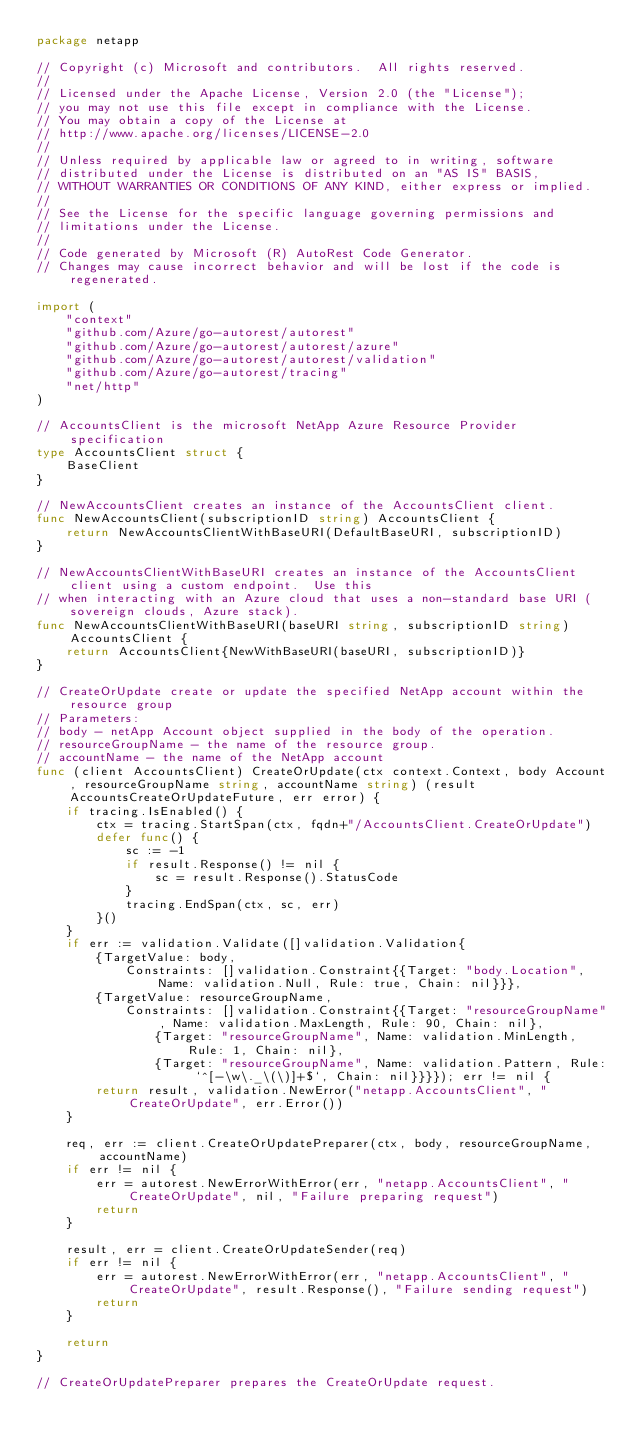Convert code to text. <code><loc_0><loc_0><loc_500><loc_500><_Go_>package netapp

// Copyright (c) Microsoft and contributors.  All rights reserved.
//
// Licensed under the Apache License, Version 2.0 (the "License");
// you may not use this file except in compliance with the License.
// You may obtain a copy of the License at
// http://www.apache.org/licenses/LICENSE-2.0
//
// Unless required by applicable law or agreed to in writing, software
// distributed under the License is distributed on an "AS IS" BASIS,
// WITHOUT WARRANTIES OR CONDITIONS OF ANY KIND, either express or implied.
//
// See the License for the specific language governing permissions and
// limitations under the License.
//
// Code generated by Microsoft (R) AutoRest Code Generator.
// Changes may cause incorrect behavior and will be lost if the code is regenerated.

import (
	"context"
	"github.com/Azure/go-autorest/autorest"
	"github.com/Azure/go-autorest/autorest/azure"
	"github.com/Azure/go-autorest/autorest/validation"
	"github.com/Azure/go-autorest/tracing"
	"net/http"
)

// AccountsClient is the microsoft NetApp Azure Resource Provider specification
type AccountsClient struct {
	BaseClient
}

// NewAccountsClient creates an instance of the AccountsClient client.
func NewAccountsClient(subscriptionID string) AccountsClient {
	return NewAccountsClientWithBaseURI(DefaultBaseURI, subscriptionID)
}

// NewAccountsClientWithBaseURI creates an instance of the AccountsClient client using a custom endpoint.  Use this
// when interacting with an Azure cloud that uses a non-standard base URI (sovereign clouds, Azure stack).
func NewAccountsClientWithBaseURI(baseURI string, subscriptionID string) AccountsClient {
	return AccountsClient{NewWithBaseURI(baseURI, subscriptionID)}
}

// CreateOrUpdate create or update the specified NetApp account within the resource group
// Parameters:
// body - netApp Account object supplied in the body of the operation.
// resourceGroupName - the name of the resource group.
// accountName - the name of the NetApp account
func (client AccountsClient) CreateOrUpdate(ctx context.Context, body Account, resourceGroupName string, accountName string) (result AccountsCreateOrUpdateFuture, err error) {
	if tracing.IsEnabled() {
		ctx = tracing.StartSpan(ctx, fqdn+"/AccountsClient.CreateOrUpdate")
		defer func() {
			sc := -1
			if result.Response() != nil {
				sc = result.Response().StatusCode
			}
			tracing.EndSpan(ctx, sc, err)
		}()
	}
	if err := validation.Validate([]validation.Validation{
		{TargetValue: body,
			Constraints: []validation.Constraint{{Target: "body.Location", Name: validation.Null, Rule: true, Chain: nil}}},
		{TargetValue: resourceGroupName,
			Constraints: []validation.Constraint{{Target: "resourceGroupName", Name: validation.MaxLength, Rule: 90, Chain: nil},
				{Target: "resourceGroupName", Name: validation.MinLength, Rule: 1, Chain: nil},
				{Target: "resourceGroupName", Name: validation.Pattern, Rule: `^[-\w\._\(\)]+$`, Chain: nil}}}}); err != nil {
		return result, validation.NewError("netapp.AccountsClient", "CreateOrUpdate", err.Error())
	}

	req, err := client.CreateOrUpdatePreparer(ctx, body, resourceGroupName, accountName)
	if err != nil {
		err = autorest.NewErrorWithError(err, "netapp.AccountsClient", "CreateOrUpdate", nil, "Failure preparing request")
		return
	}

	result, err = client.CreateOrUpdateSender(req)
	if err != nil {
		err = autorest.NewErrorWithError(err, "netapp.AccountsClient", "CreateOrUpdate", result.Response(), "Failure sending request")
		return
	}

	return
}

// CreateOrUpdatePreparer prepares the CreateOrUpdate request.</code> 